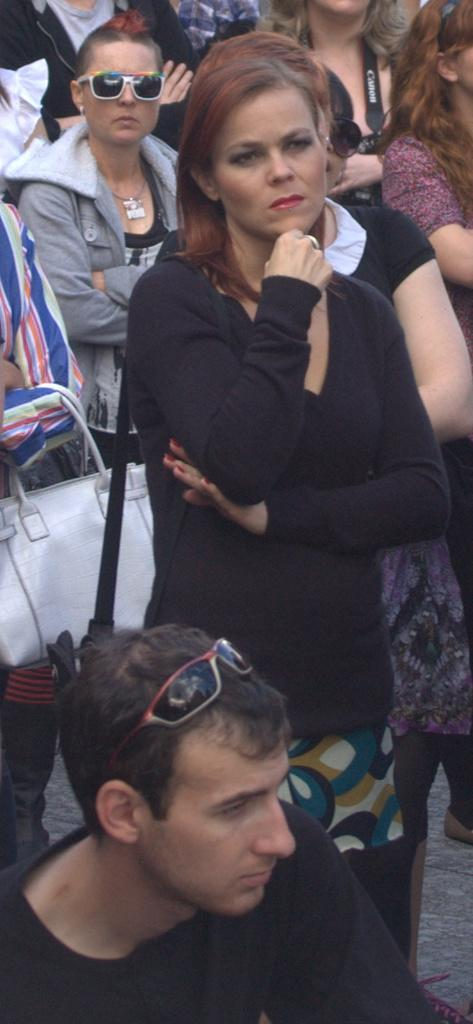How many people are in the image? There are many people in the image. Can you describe the person on the left side of the image? The person on the left side of the image is holding a purse. What is the person at the bottom of the image wearing? The person at the bottom of the image is wearing a spec. How many children are playing with the pump in the image? There is no pump or children present in the image. 